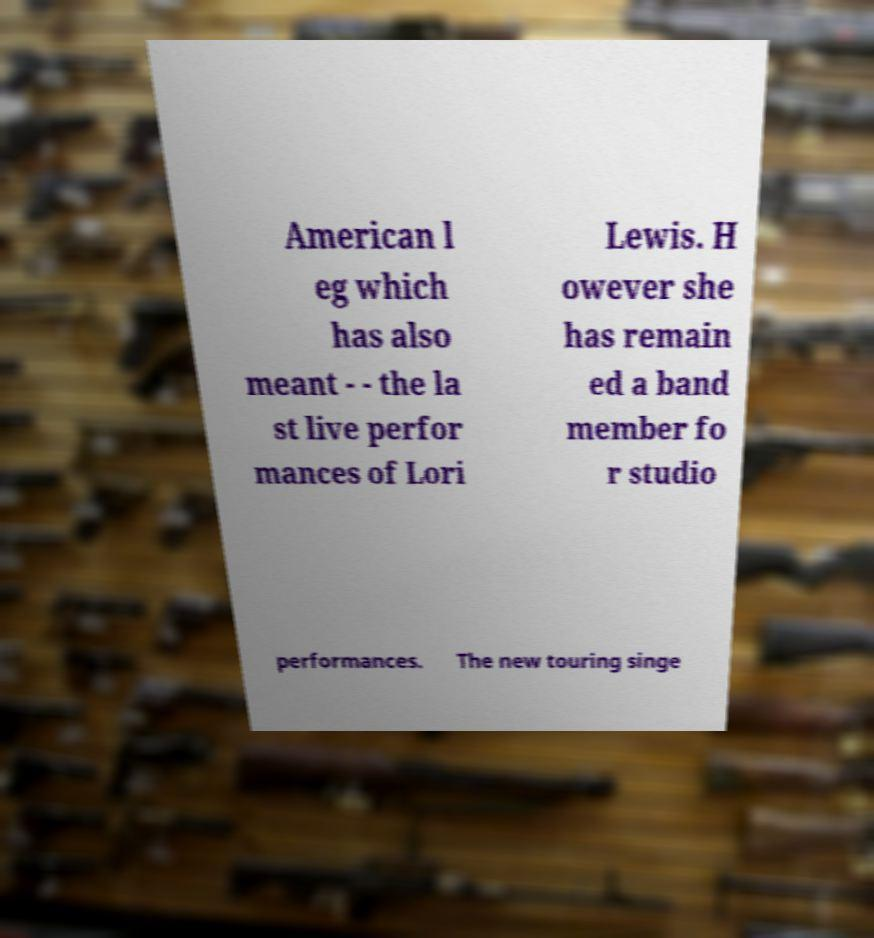I need the written content from this picture converted into text. Can you do that? American l eg which has also meant - - the la st live perfor mances of Lori Lewis. H owever she has remain ed a band member fo r studio performances. The new touring singe 